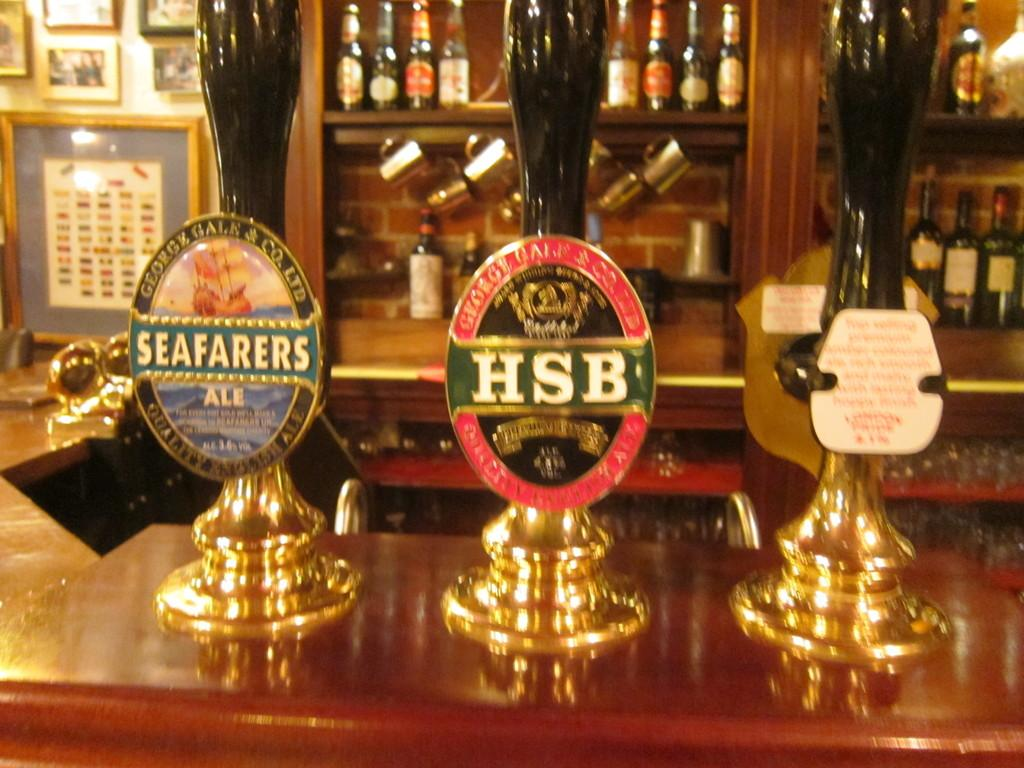<image>
Share a concise interpretation of the image provided. One of the taps on the bar has the letters HSB on it 